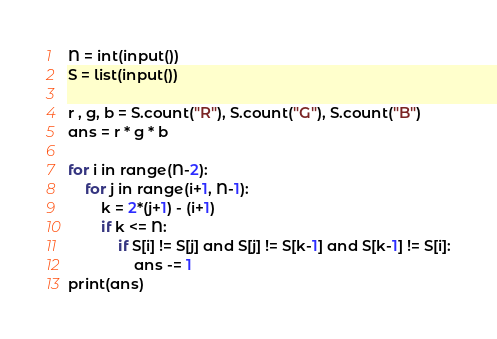Convert code to text. <code><loc_0><loc_0><loc_500><loc_500><_Python_>N = int(input())
S = list(input())

r , g, b = S.count("R"), S.count("G"), S.count("B")
ans = r * g * b

for i in range(N-2):
    for j in range(i+1, N-1):
        k = 2*(j+1) - (i+1)
        if k <= N:
            if S[i] != S[j] and S[j] != S[k-1] and S[k-1] != S[i]:
            	ans -= 1
print(ans)</code> 